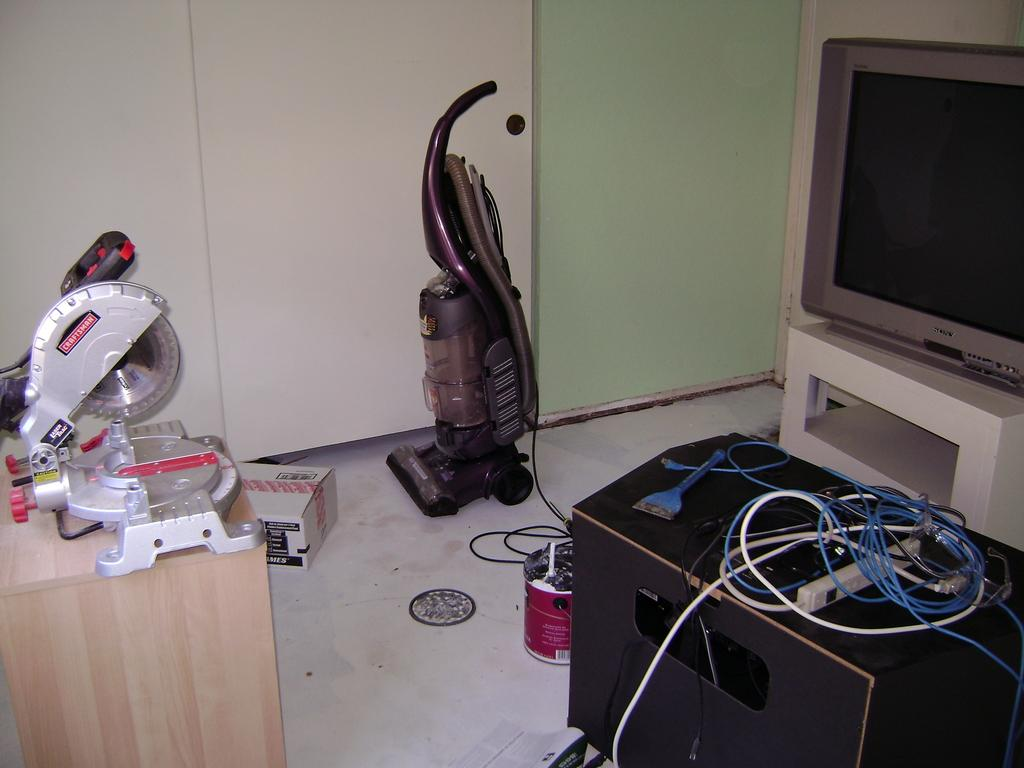What type of objects can be seen in the image? There are electronic gadgets in the image. Can you describe the electronic gadgets in the image? The electronic gadgets come in different colors. What is one specific electronic gadget that can be seen in the image? There is a television in the image. What is the purpose of the cardboard box in the image? The purpose of the cardboard box in the image is not clear, but it might be used for storage or transportation. What is the background of the image? There is a wall in the image. Are there any other objects in the image besides the electronic gadgets and the cardboard box? Yes, there are other objects in the image. Can you see any sparks coming from the electronic gadgets in the image? No, there are no sparks visible in the image. Are there any drains visible in the image? No, there are no drains present in the image. 